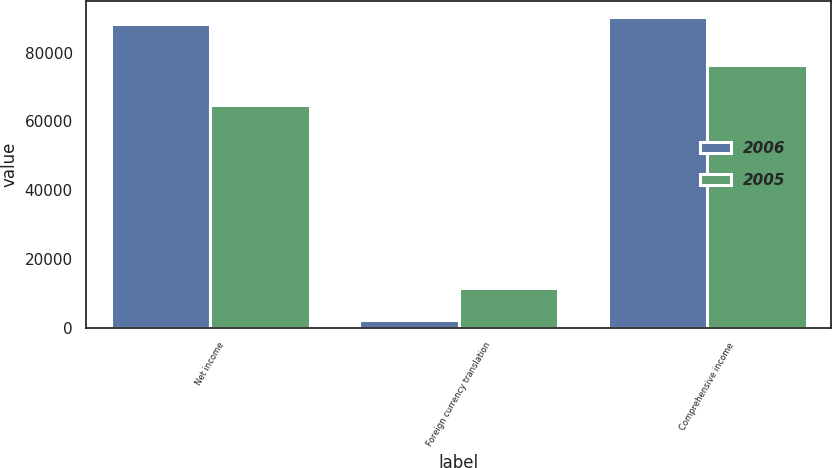Convert chart. <chart><loc_0><loc_0><loc_500><loc_500><stacked_bar_chart><ecel><fcel>Net income<fcel>Foreign currency translation<fcel>Comprehensive income<nl><fcel>2006<fcel>88211<fcel>2250<fcel>90461<nl><fcel>2005<fcel>64785<fcel>11617<fcel>76396<nl></chart> 